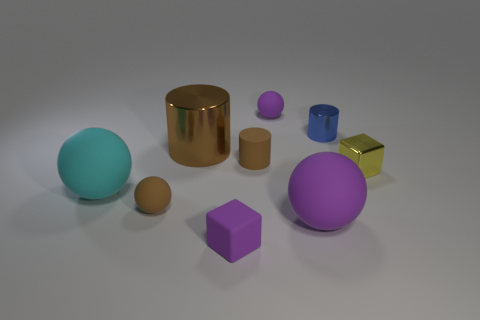Subtract 1 balls. How many balls are left? 3 Subtract all green blocks. Subtract all gray spheres. How many blocks are left? 2 Add 1 large gray matte cylinders. How many objects exist? 10 Subtract all spheres. How many objects are left? 5 Add 4 green rubber things. How many green rubber things exist? 4 Subtract 0 gray balls. How many objects are left? 9 Subtract all purple rubber spheres. Subtract all big cyan matte spheres. How many objects are left? 6 Add 2 small rubber objects. How many small rubber objects are left? 6 